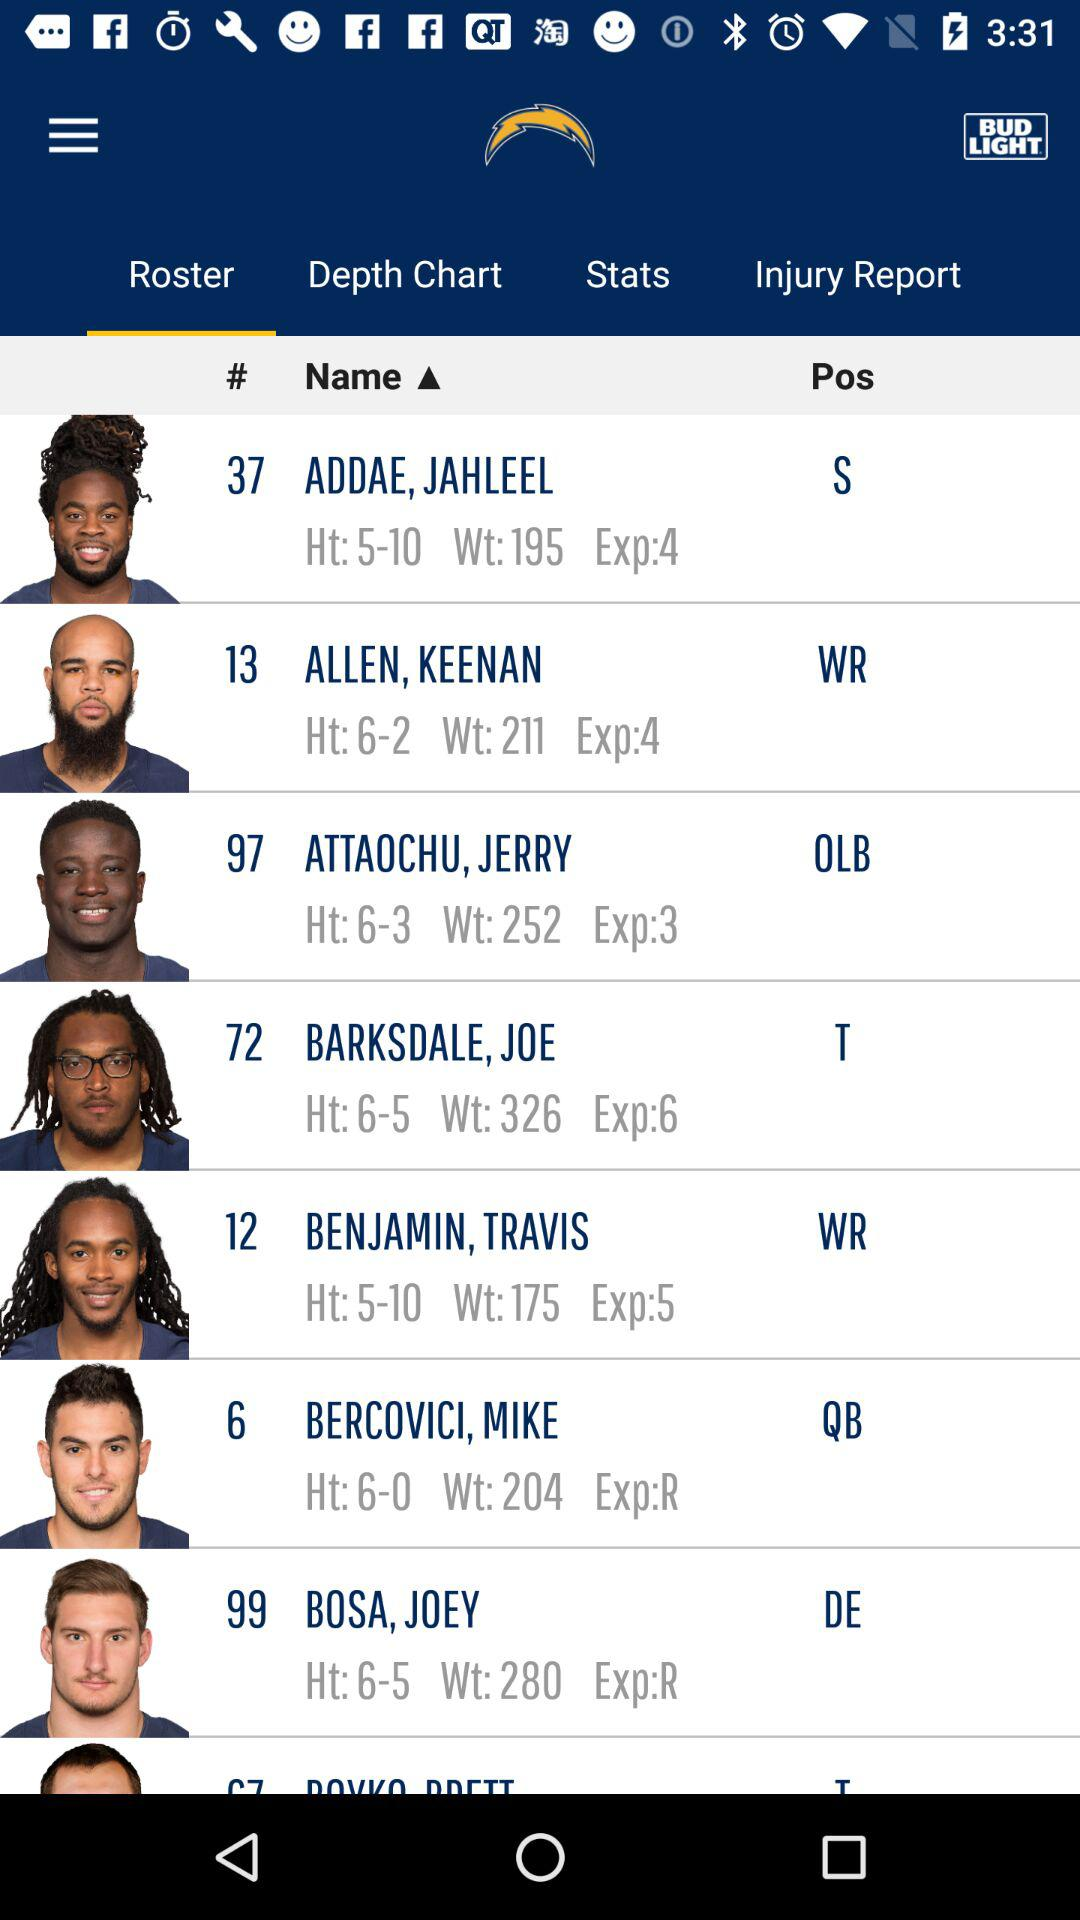What player's weight is 211? 211 is the weight of Keenan Allen. 